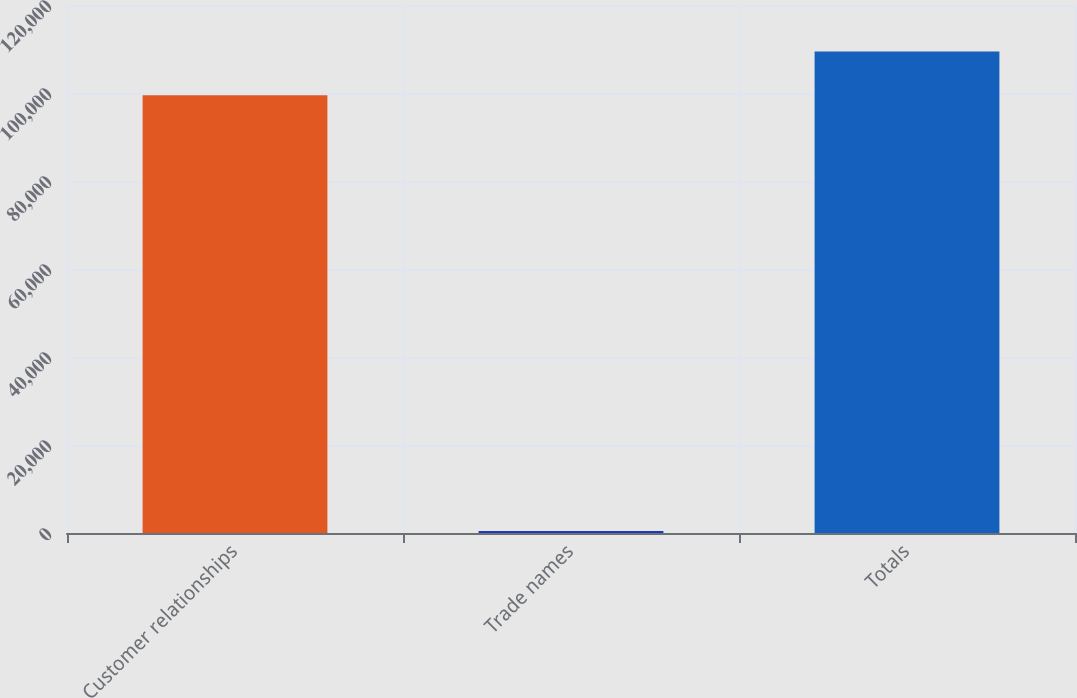<chart> <loc_0><loc_0><loc_500><loc_500><bar_chart><fcel>Customer relationships<fcel>Trade names<fcel>Totals<nl><fcel>99484<fcel>467<fcel>109432<nl></chart> 